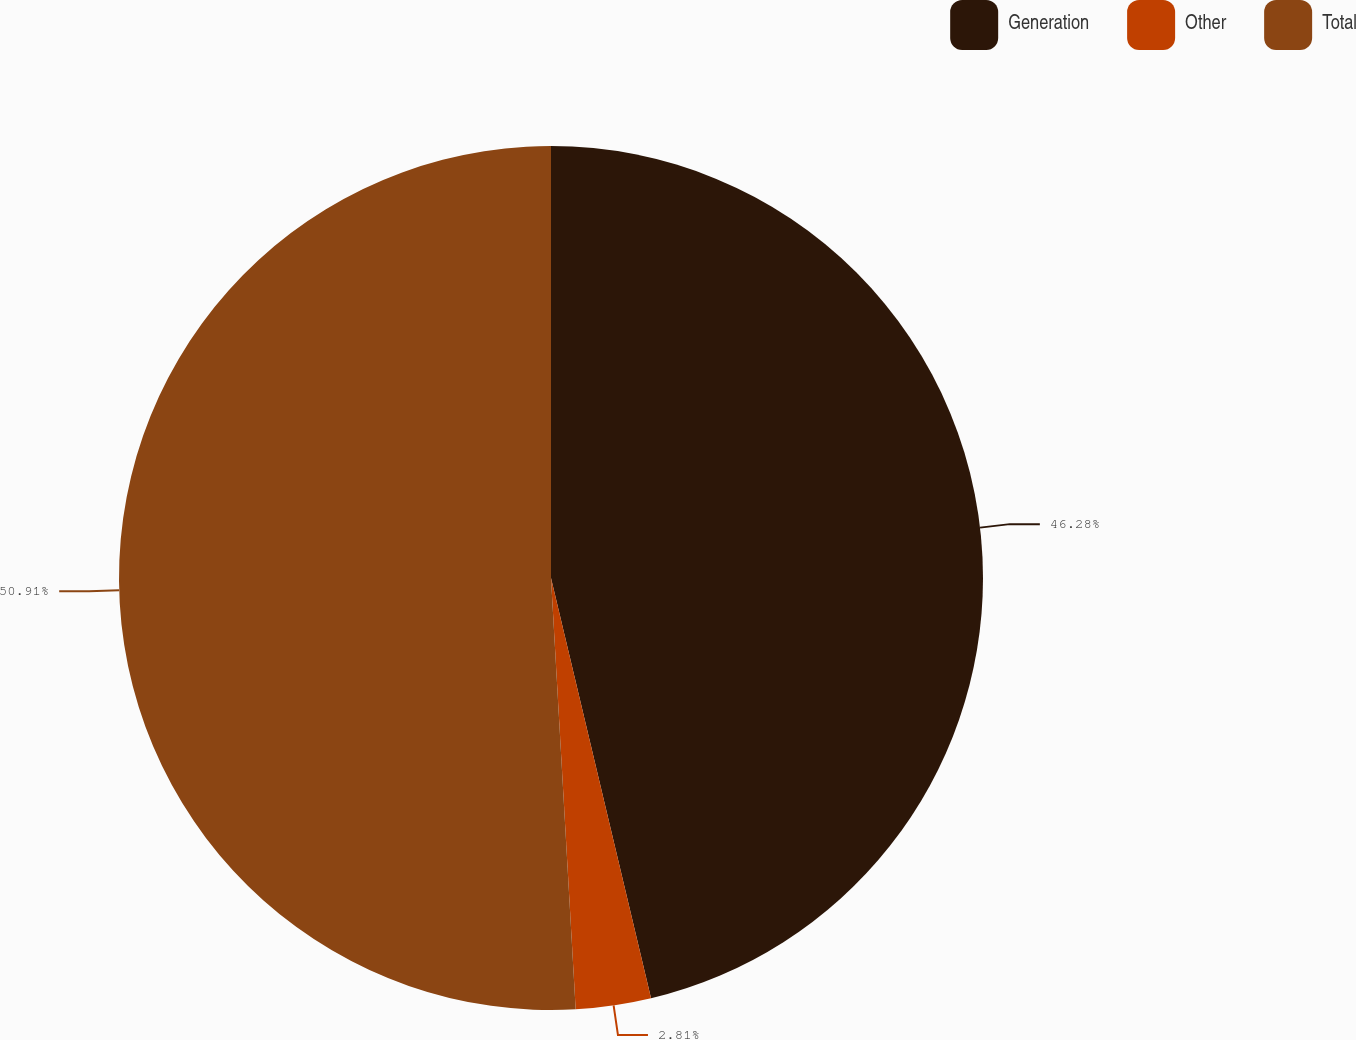Convert chart to OTSL. <chart><loc_0><loc_0><loc_500><loc_500><pie_chart><fcel>Generation<fcel>Other<fcel>Total<nl><fcel>46.28%<fcel>2.81%<fcel>50.91%<nl></chart> 